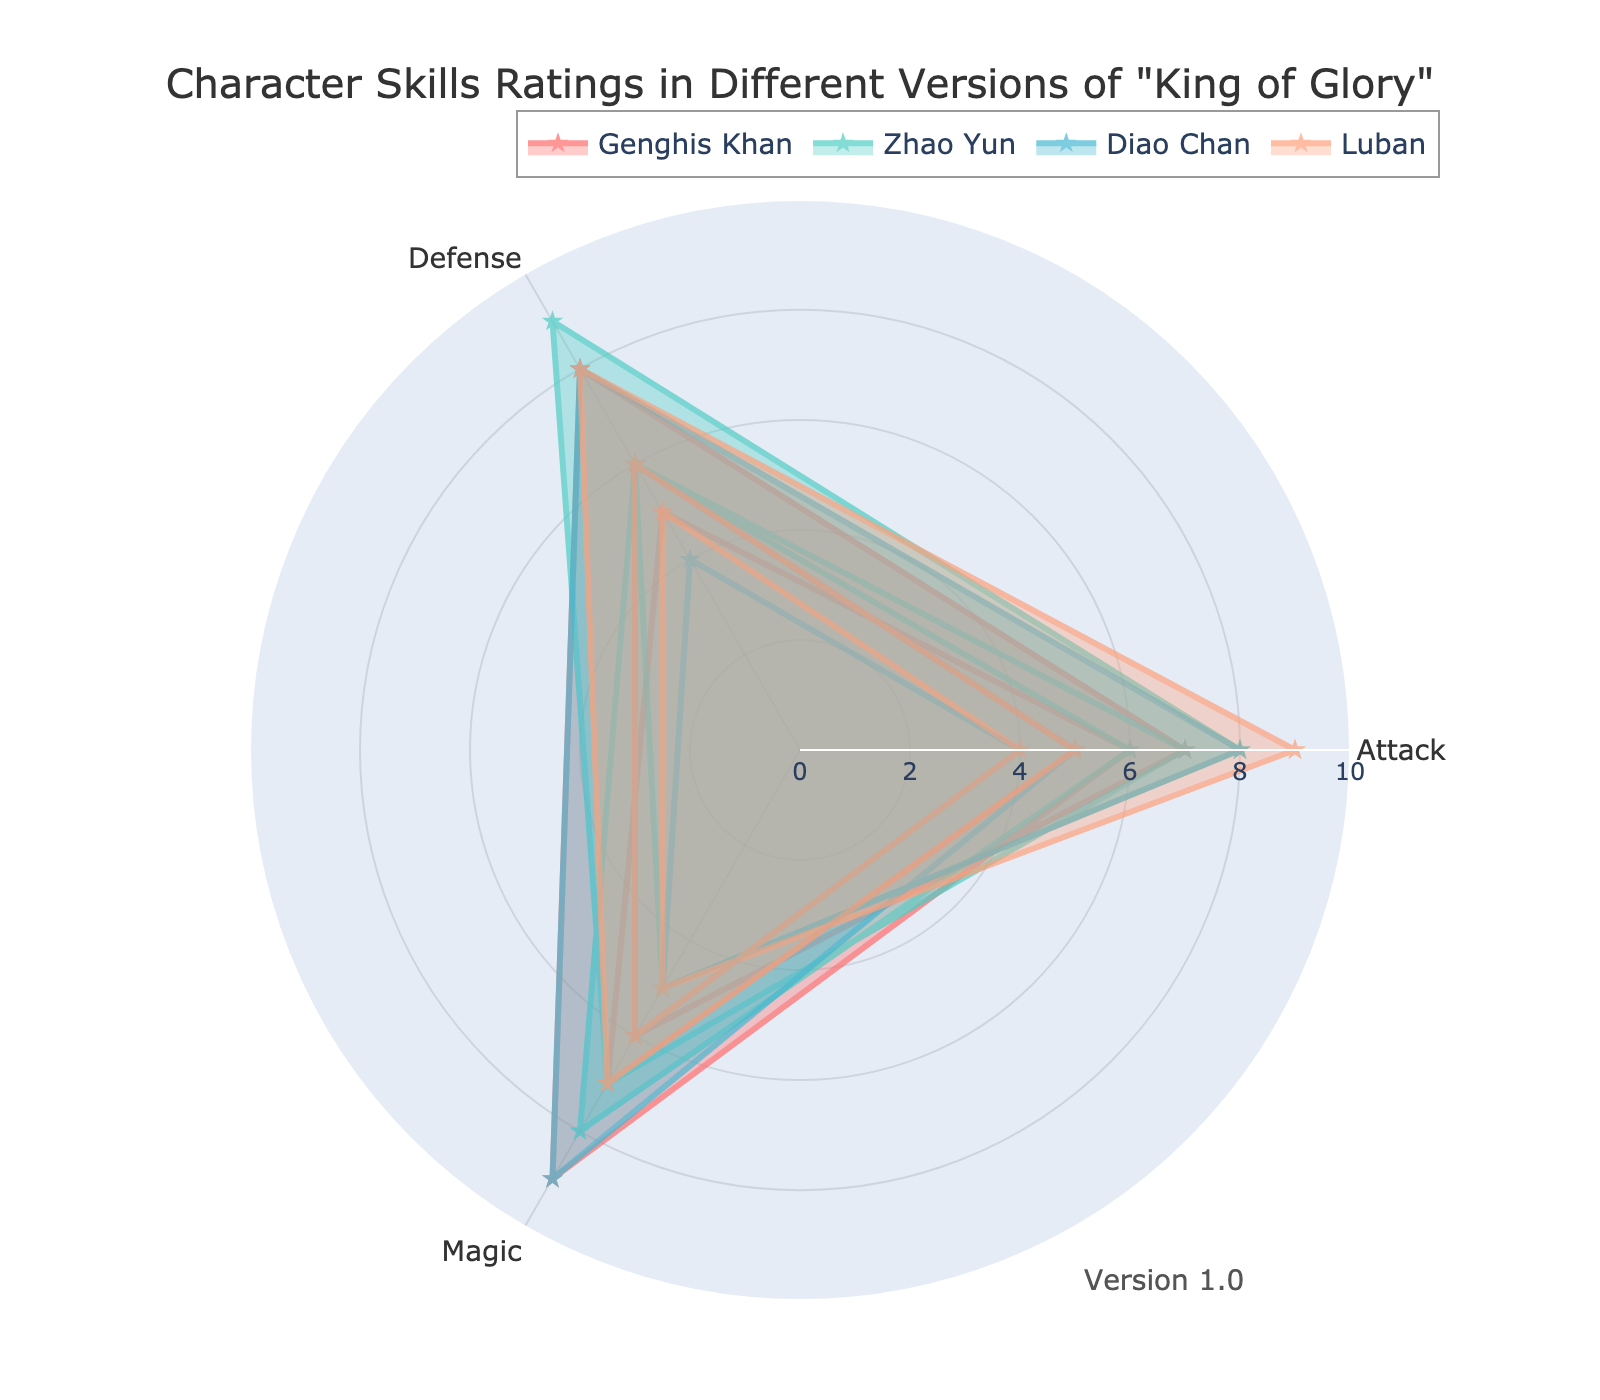What's the title of the radar chart? The title can typically be found at the top of the radar chart. In this case, it says "Character Skills Ratings in Different Versions of 'King of Glory'".
Answer: Character Skills Ratings in Different Versions of "King of Glory" How many versions are represented in the radar chart? In a radar chart, different versions can be identified through annotations or labels. Here, we see labels corresponding to three versions: Version 1.0, Version 2.0, and Version 3.0.
Answer: 3 Which character has the highest Attack skill rating in Version 1.0? By examining the radar chart, you can inspect the positions and ratings for the Attack skill in Version 1.0 for each character. Genghis Khan has a rating of 7, Zhao Yun has 8, Diao Chan has 5, and Luban has 9.
Answer: Luban Which character experienced the greatest increase in Defense rating from Version 2.0 to Version 3.0? Looking at the Defense skill ratings: Genghis Khan increased from 5 to 7 (+2), Zhao Yun increased from 6 to 8 (+2), Diao Chan increased from 4 to 5 (+1), and Luban remained at 6 (0). Both Genghis Khan and Zhao Yun experienced an increase of 2.
Answer: Genghis Khan and Zhao Yun Calculate the average Magic rating for Diao Chan across all versions. To find the average, sum the values (8 + 8 + 9) and divide by the number of entries, which is 3. Therefore, (8 + 8 + 9) / 3 = 25 / 3 ≈ 8.33.
Answer: 8.33 Which character saw a decrease in their Attack rating from Version 2.0 to Version 3.0? By comparing Attack ratings between the two versions: Genghis Khan 8 to 9 (increase), Zhao Yun 9 to 7 (decrease), Diao Chan 6 to 6 (no change), and Luban 8 to 7 (decrease).
Answer: Zhao Yun and Luban Among all characters, whose average Defense rating is the lowest? Calculate the average Defense rating for each character and compare: Genghis Khan (6 + 5 + 7) / 3 = 6, Zhao Yun (7 + 6 + 8) / 3 = 7, Diao Chan (4 + 4 + 5) / 3 = 4.33, Luban (5 + 6 + 6) / 3 = 5.67. The lowest is Diao Chan with 4.33.
Answer: Diao Chan Which character has the most balanced skill ratings across all versions, meaning the least difference between their highest and lowest ratings? For each character, find the range (max - min) for their ratings across all skills and versions. Smaller ranges indicate a more balanced rating. Genghis Khan: max 9 - min 5 = 4, Zhao Yun: max 9 - min 5 = 4, Diao Chan: max 9 - min 4 = 5, Luban: max 9 - min 4 = 5.
Answer: Genghis Khan and Zhao Yun Which skill improved the most for Luban from Version 1.0 to Version 2.0? Compare Luban's skills from Version 1.0 to Version 2.0: Attack (9 to 8, decrease), Defense (5 to 6, increase by 1), Magic (4 to 5, increase by 1). The largest improvement is in Defense and Magic, both by 1 point.
Answer: Defense and Magic If you sum up the Attack ratings of all characters in Version 3.0, what is the total? Sum the Attack ratings for Version 3.0: Genghis Khan (9), Zhao Yun (7), Diao Chan (6), Luban (7). Therefore, 9 + 7 + 6 + 7 = 29.
Answer: 29 